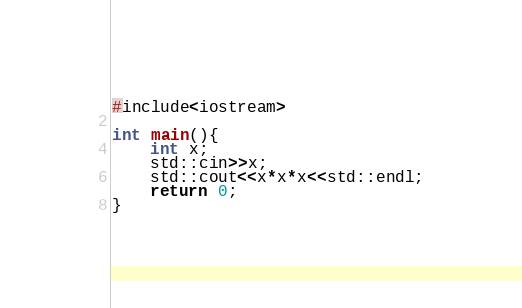<code> <loc_0><loc_0><loc_500><loc_500><_Java_>#include<iostream>

int main(){
    int x;
    std::cin>>x;
    std::cout<<x*x*x<<std::endl;
    return 0;
}
</code> 